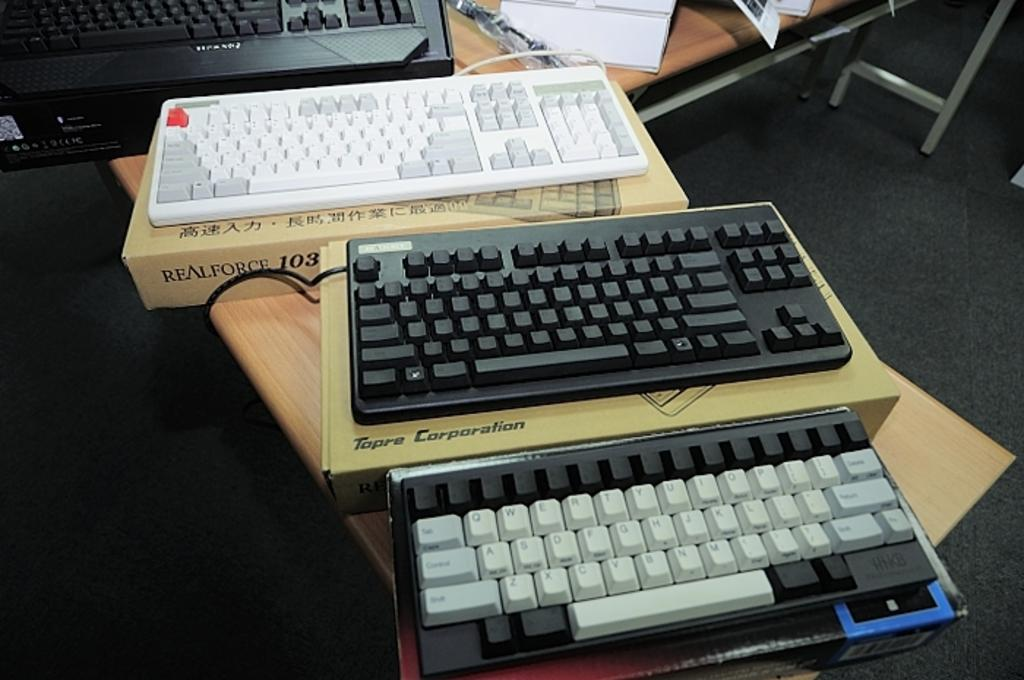<image>
Relay a brief, clear account of the picture shown. A Realforce keyboard above a Tapre corp keyboard above another keyboard. 